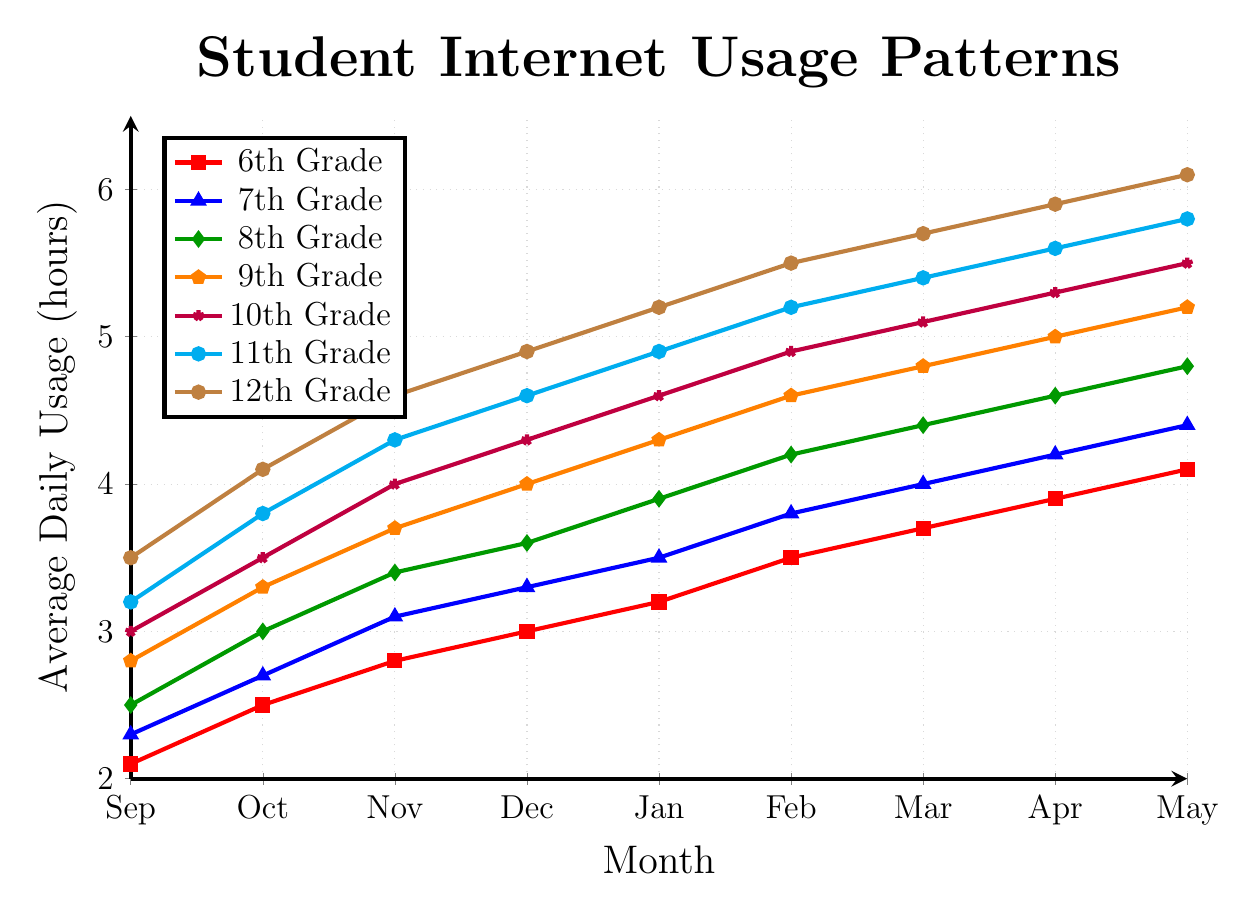Which grade level showed the highest average daily usage in May? Looking at the highest points on the graph for each grade level in May, we find that the 12th Grade shows the highest average daily usage, which is approximately 6.1 hours.
Answer: 12th Grade Which two grade levels had the most similar internet usage patterns throughout the school year? By examining the overall trends and closeness of the lines on the chart, 11th and 12th Grades show the most similar patterns as their lines run very close together across all months.
Answer: 11th and 12th Grades How much did the average daily usage increase from September to May for the 7th Grade? The average daily usage for 7th Grade in September is 2.3 hours and in May it is 4.4 hours. The increase is calculated as 4.4 - 2.3 = 2.1 hours.
Answer: 2.1 hours What is the average daily usage in March for all grades combined? To find the overall average for March, sum the usage hours for each grade and divide by the number of grades: (3.7 + 4.0 + 4.4 + 4.8 + 5.1 + 5.4 + 5.7) / 7 = 33.1 / 7 ≈ 4.73 hours.
Answer: 4.73 hours Which grade level showed the least growth from September to May? By comparing the usage growth from September to May across all grades, 6th Grade shows the least growth: 4.1 - 2.1 = 2.0 hours, which is the smallest increase among all grades.
Answer: 6th Grade During which month did the 8th Grade's average daily usage first exceed 4 hours? Referencing the plotted line for 8th Grade, the average daily usage first exceeds 4 hours in January, where it records 4.2 hours.
Answer: January How does the usage in February for the 10th Grade compare to the usage in November for the 12th Grade? February usage for 10th Grade is 4.9 hours and November usage for 12th Grade is 4.6 hours. Hence, the 10th Grade February usage is higher by 0.3 hours.
Answer: 10th Grade February is higher What is the median average daily usage in January across all grades? List the January usage values for all grades: 3.2, 3.5, 3.9, 4.3, 4.6, 4.9, 5.2. The median value is the 4th value in this sorted list, which is 4.3 hours.
Answer: 4.3 hours How much did the average daily usage increase for the 12th Grade from December to January? The usage in December for the 12th Grade is 4.9 hours, and in January, it is 5.2 hours. The increase is calculated as 5.2 - 4.9 = 0.3 hours.
Answer: 0.3 hours 